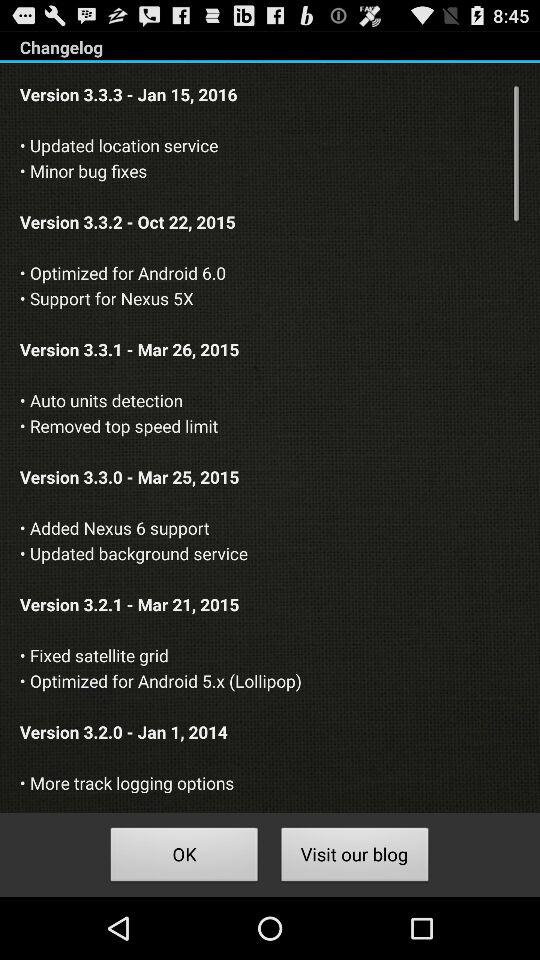Which version provides more track tracking options? The version is 3.2.0. 